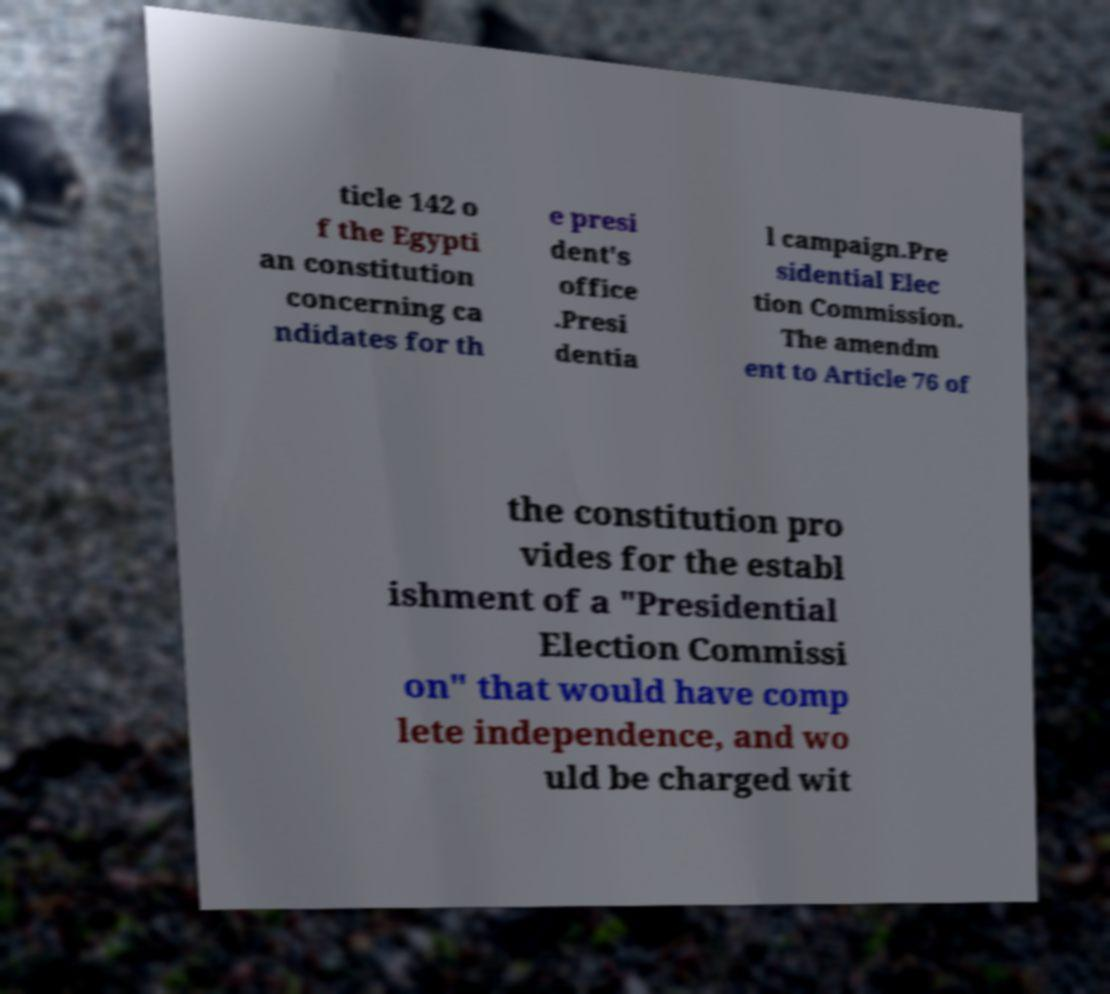What messages or text are displayed in this image? I need them in a readable, typed format. ticle 142 o f the Egypti an constitution concerning ca ndidates for th e presi dent's office .Presi dentia l campaign.Pre sidential Elec tion Commission. The amendm ent to Article 76 of the constitution pro vides for the establ ishment of a "Presidential Election Commissi on" that would have comp lete independence, and wo uld be charged wit 